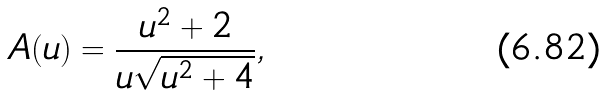Convert formula to latex. <formula><loc_0><loc_0><loc_500><loc_500>A ( u ) = \frac { u ^ { 2 } + 2 } { u \sqrt { u ^ { 2 } + 4 } } ,</formula> 